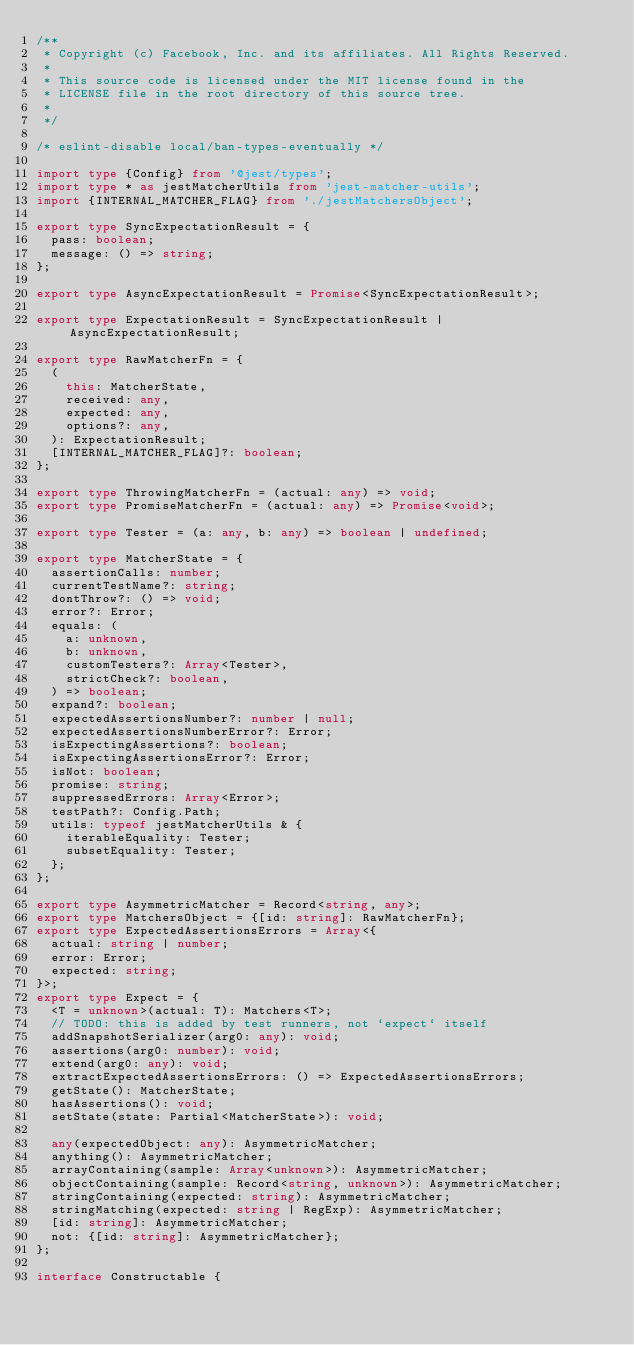<code> <loc_0><loc_0><loc_500><loc_500><_TypeScript_>/**
 * Copyright (c) Facebook, Inc. and its affiliates. All Rights Reserved.
 *
 * This source code is licensed under the MIT license found in the
 * LICENSE file in the root directory of this source tree.
 *
 */

/* eslint-disable local/ban-types-eventually */

import type {Config} from '@jest/types';
import type * as jestMatcherUtils from 'jest-matcher-utils';
import {INTERNAL_MATCHER_FLAG} from './jestMatchersObject';

export type SyncExpectationResult = {
  pass: boolean;
  message: () => string;
};

export type AsyncExpectationResult = Promise<SyncExpectationResult>;

export type ExpectationResult = SyncExpectationResult | AsyncExpectationResult;

export type RawMatcherFn = {
  (
    this: MatcherState,
    received: any,
    expected: any,
    options?: any,
  ): ExpectationResult;
  [INTERNAL_MATCHER_FLAG]?: boolean;
};

export type ThrowingMatcherFn = (actual: any) => void;
export type PromiseMatcherFn = (actual: any) => Promise<void>;

export type Tester = (a: any, b: any) => boolean | undefined;

export type MatcherState = {
  assertionCalls: number;
  currentTestName?: string;
  dontThrow?: () => void;
  error?: Error;
  equals: (
    a: unknown,
    b: unknown,
    customTesters?: Array<Tester>,
    strictCheck?: boolean,
  ) => boolean;
  expand?: boolean;
  expectedAssertionsNumber?: number | null;
  expectedAssertionsNumberError?: Error;
  isExpectingAssertions?: boolean;
  isExpectingAssertionsError?: Error;
  isNot: boolean;
  promise: string;
  suppressedErrors: Array<Error>;
  testPath?: Config.Path;
  utils: typeof jestMatcherUtils & {
    iterableEquality: Tester;
    subsetEquality: Tester;
  };
};

export type AsymmetricMatcher = Record<string, any>;
export type MatchersObject = {[id: string]: RawMatcherFn};
export type ExpectedAssertionsErrors = Array<{
  actual: string | number;
  error: Error;
  expected: string;
}>;
export type Expect = {
  <T = unknown>(actual: T): Matchers<T>;
  // TODO: this is added by test runners, not `expect` itself
  addSnapshotSerializer(arg0: any): void;
  assertions(arg0: number): void;
  extend(arg0: any): void;
  extractExpectedAssertionsErrors: () => ExpectedAssertionsErrors;
  getState(): MatcherState;
  hasAssertions(): void;
  setState(state: Partial<MatcherState>): void;

  any(expectedObject: any): AsymmetricMatcher;
  anything(): AsymmetricMatcher;
  arrayContaining(sample: Array<unknown>): AsymmetricMatcher;
  objectContaining(sample: Record<string, unknown>): AsymmetricMatcher;
  stringContaining(expected: string): AsymmetricMatcher;
  stringMatching(expected: string | RegExp): AsymmetricMatcher;
  [id: string]: AsymmetricMatcher;
  not: {[id: string]: AsymmetricMatcher};
};

interface Constructable {</code> 